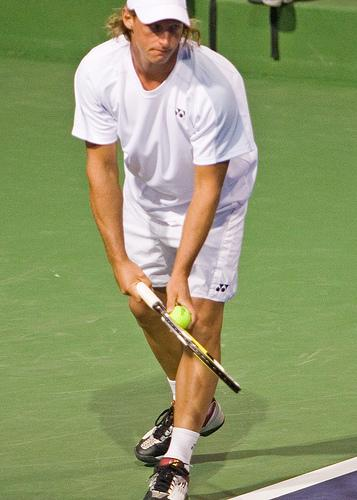Elaborate on the image's essential subject and their ongoing action. A determined tennis player, dressed in a crisp white uniform and hat, grips his racket and ball and gets set for a powerful serve on the green court. Portray the primary individual and activity depicted in the image. An athletic man clad in white tennis attire and hat, stands poised with his racket and ball, preparing for his next serve on the court. Narrate the primary activity taking place in the image. Tennis player with white hat and attire, holding ball and racket aiming to serve on the green court. Provide a concise summary of the primary subject and their actions in the image. A male tennis player in a white uniform with a cap is preparing for a serve, holding a ball and racket. Offer a colourful narrative of the central theme in the image. On a lush tennis court, an athlete adorned in pristine white, brandishes his racket and ball, steeling himself for an exhilarating serve. Explain the scene captured in the image using concise language. Man in tennis attire with cap and racket, ready to serve a yellow ball in a green court setting. Provide a brief description of the primary focus in the image. A tennis player wearing a white uniform and hat prepares to serve the ball, holding a racket and tennis ball. Describe the image's central action using vivid language. A tennis player, clad in an all-white ensemble, poised to unleash a powerful serve while clutching a vibrant yellow ball and racket. Give a detailed account of the main focal point in the image and their activity. A man donning a white tennis outfit, cap, and sneakers, ready to serve with a tennis racket and yellow-green ball in hand. Describe the leading character and their conduct in the image. A blonde, white-capped tennis player in a full white tennis outfit is ready to serve the ball, holding his racket and ball in hand. 